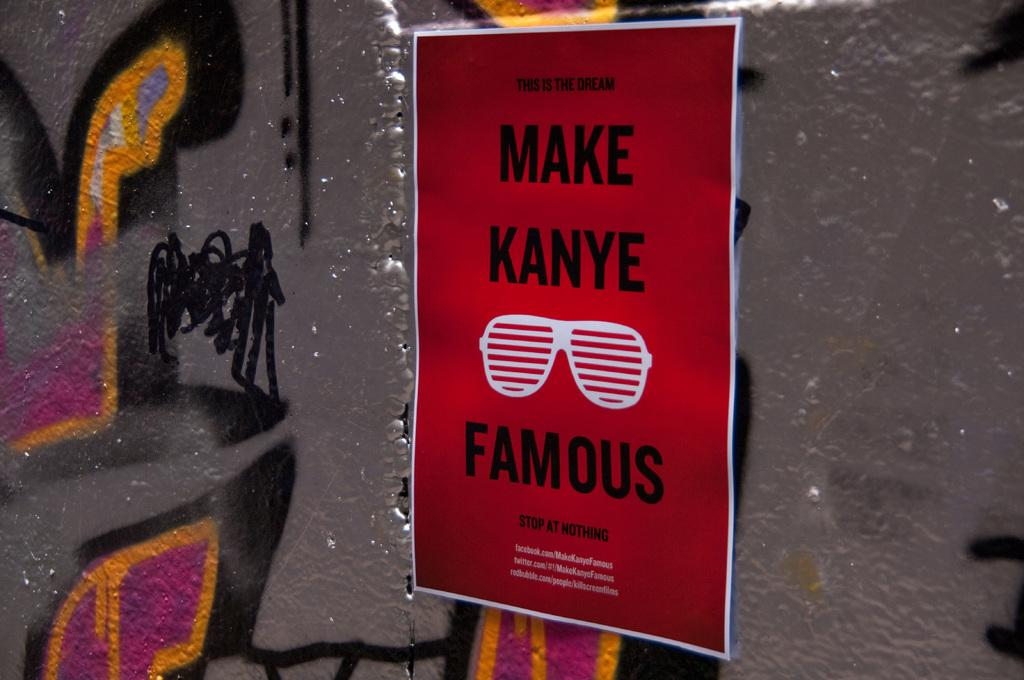<image>
Provide a brief description of the given image. A red poster on a wall saying "MAKE KANYE FAMOUS" 